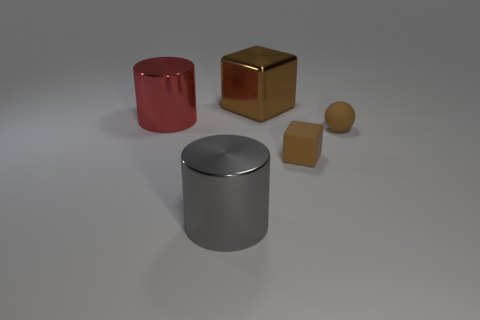There is a big object that is the same color as the ball; what is it made of?
Ensure brevity in your answer.  Metal. How many objects are big gray objects or brown rubber cubes?
Your answer should be very brief. 2. The brown matte object left of the tiny brown rubber object to the right of the tiny thing in front of the brown sphere is what shape?
Keep it short and to the point. Cube. Is the material of the brown object left of the tiny rubber block the same as the big cylinder behind the gray metal cylinder?
Give a very brief answer. Yes. What material is the red thing that is the same shape as the gray thing?
Your answer should be very brief. Metal. There is a big thing that is in front of the tiny rubber sphere; is it the same shape as the metal object that is behind the big red metal cylinder?
Provide a short and direct response. No. Is the number of red metallic things that are right of the gray metallic thing less than the number of matte blocks in front of the red object?
Your answer should be very brief. Yes. What number of other objects are there of the same shape as the brown shiny object?
Provide a succinct answer. 1. The red thing that is made of the same material as the gray cylinder is what shape?
Your answer should be compact. Cylinder. What is the color of the thing that is right of the big brown cube and behind the small block?
Your response must be concise. Brown. 